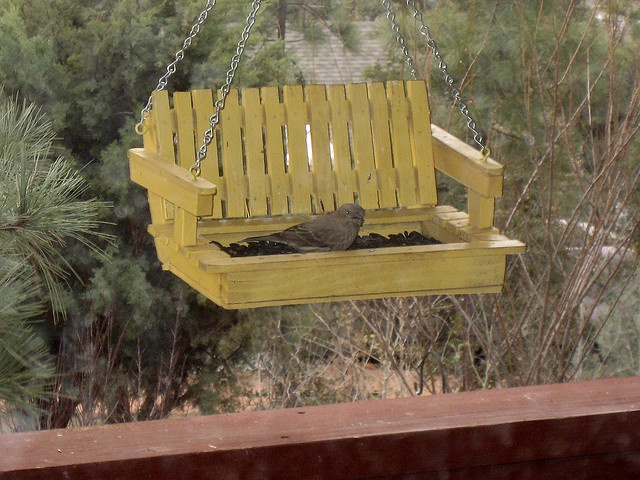Describe the objects in this image and their specific colors. I can see bench in tan and olive tones and bird in tan, gray, and black tones in this image. 